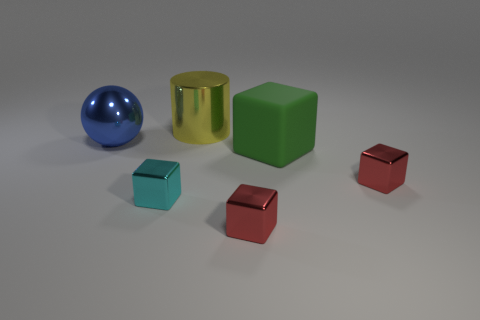Is the material of the big object on the right side of the big cylinder the same as the blue ball?
Your response must be concise. No. What material is the small object that is left of the large yellow shiny object that is on the right side of the big metal object that is in front of the large yellow object?
Offer a terse response. Metal. Is there anything else that is the same size as the cyan thing?
Ensure brevity in your answer.  Yes. How many rubber things are either yellow cubes or big cylinders?
Your response must be concise. 0. Are any metal objects visible?
Your answer should be compact. Yes. What color is the shiny cube to the left of the tiny red metallic object that is in front of the tiny cyan block?
Your answer should be very brief. Cyan. How many other things are the same color as the large cube?
Your answer should be compact. 0. How many things are big green objects or tiny objects to the right of the green matte cube?
Provide a short and direct response. 2. There is a shiny thing that is in front of the tiny cyan shiny thing; what is its color?
Make the answer very short. Red. The blue object is what shape?
Your answer should be very brief. Sphere. 